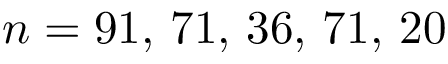Convert formula to latex. <formula><loc_0><loc_0><loc_500><loc_500>n = 9 1 , \, 7 1 , \, 3 6 , \, 7 1 , \, 2 0</formula> 